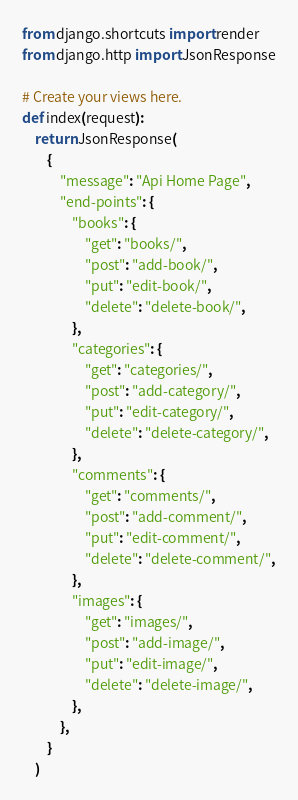Convert code to text. <code><loc_0><loc_0><loc_500><loc_500><_Python_>from django.shortcuts import render
from django.http import JsonResponse

# Create your views here.
def index(request):
    return JsonResponse(
        {
            "message": "Api Home Page",
            "end-points": {
                "books": {
                    "get": "books/",
                    "post": "add-book/",
                    "put": "edit-book/",
                    "delete": "delete-book/",
                },
                "categories": {
                    "get": "categories/",
                    "post": "add-category/",
                    "put": "edit-category/",
                    "delete": "delete-category/",
                },
                "comments": {
                    "get": "comments/",
                    "post": "add-comment/",
                    "put": "edit-comment/",
                    "delete": "delete-comment/",
                },
                "images": {
                    "get": "images/",
                    "post": "add-image/",
                    "put": "edit-image/",
                    "delete": "delete-image/",
                },
            },
        }
    )
</code> 